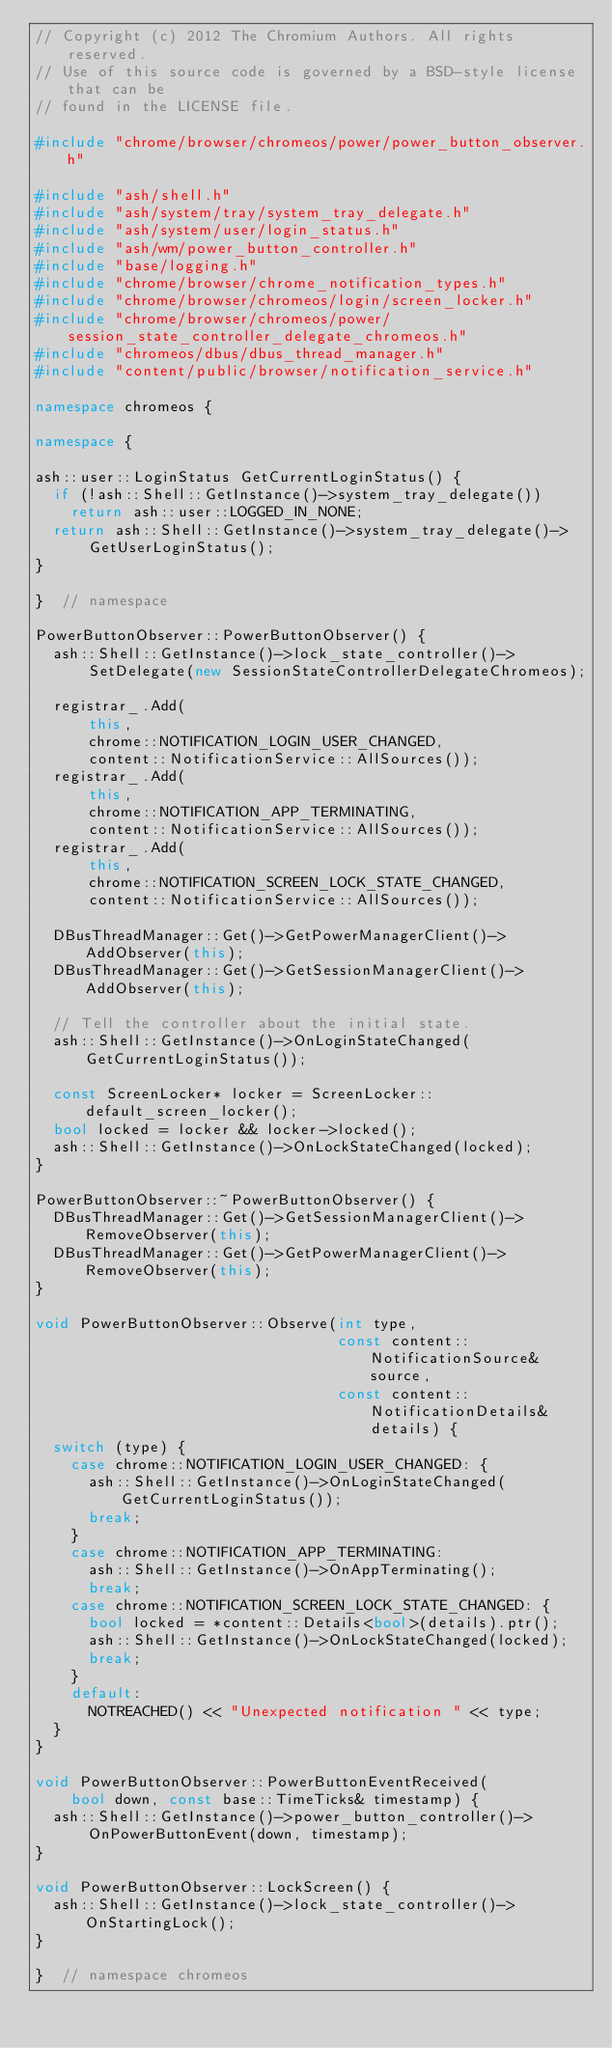Convert code to text. <code><loc_0><loc_0><loc_500><loc_500><_C++_>// Copyright (c) 2012 The Chromium Authors. All rights reserved.
// Use of this source code is governed by a BSD-style license that can be
// found in the LICENSE file.

#include "chrome/browser/chromeos/power/power_button_observer.h"

#include "ash/shell.h"
#include "ash/system/tray/system_tray_delegate.h"
#include "ash/system/user/login_status.h"
#include "ash/wm/power_button_controller.h"
#include "base/logging.h"
#include "chrome/browser/chrome_notification_types.h"
#include "chrome/browser/chromeos/login/screen_locker.h"
#include "chrome/browser/chromeos/power/session_state_controller_delegate_chromeos.h"
#include "chromeos/dbus/dbus_thread_manager.h"
#include "content/public/browser/notification_service.h"

namespace chromeos {

namespace {

ash::user::LoginStatus GetCurrentLoginStatus() {
  if (!ash::Shell::GetInstance()->system_tray_delegate())
    return ash::user::LOGGED_IN_NONE;
  return ash::Shell::GetInstance()->system_tray_delegate()->
      GetUserLoginStatus();
}

}  // namespace

PowerButtonObserver::PowerButtonObserver() {
  ash::Shell::GetInstance()->lock_state_controller()->
      SetDelegate(new SessionStateControllerDelegateChromeos);

  registrar_.Add(
      this,
      chrome::NOTIFICATION_LOGIN_USER_CHANGED,
      content::NotificationService::AllSources());
  registrar_.Add(
      this,
      chrome::NOTIFICATION_APP_TERMINATING,
      content::NotificationService::AllSources());
  registrar_.Add(
      this,
      chrome::NOTIFICATION_SCREEN_LOCK_STATE_CHANGED,
      content::NotificationService::AllSources());

  DBusThreadManager::Get()->GetPowerManagerClient()->AddObserver(this);
  DBusThreadManager::Get()->GetSessionManagerClient()->AddObserver(this);

  // Tell the controller about the initial state.
  ash::Shell::GetInstance()->OnLoginStateChanged(GetCurrentLoginStatus());

  const ScreenLocker* locker = ScreenLocker::default_screen_locker();
  bool locked = locker && locker->locked();
  ash::Shell::GetInstance()->OnLockStateChanged(locked);
}

PowerButtonObserver::~PowerButtonObserver() {
  DBusThreadManager::Get()->GetSessionManagerClient()->RemoveObserver(this);
  DBusThreadManager::Get()->GetPowerManagerClient()->RemoveObserver(this);
}

void PowerButtonObserver::Observe(int type,
                                  const content::NotificationSource& source,
                                  const content::NotificationDetails& details) {
  switch (type) {
    case chrome::NOTIFICATION_LOGIN_USER_CHANGED: {
      ash::Shell::GetInstance()->OnLoginStateChanged(GetCurrentLoginStatus());
      break;
    }
    case chrome::NOTIFICATION_APP_TERMINATING:
      ash::Shell::GetInstance()->OnAppTerminating();
      break;
    case chrome::NOTIFICATION_SCREEN_LOCK_STATE_CHANGED: {
      bool locked = *content::Details<bool>(details).ptr();
      ash::Shell::GetInstance()->OnLockStateChanged(locked);
      break;
    }
    default:
      NOTREACHED() << "Unexpected notification " << type;
  }
}

void PowerButtonObserver::PowerButtonEventReceived(
    bool down, const base::TimeTicks& timestamp) {
  ash::Shell::GetInstance()->power_button_controller()->
      OnPowerButtonEvent(down, timestamp);
}

void PowerButtonObserver::LockScreen() {
  ash::Shell::GetInstance()->lock_state_controller()->OnStartingLock();
}

}  // namespace chromeos
</code> 